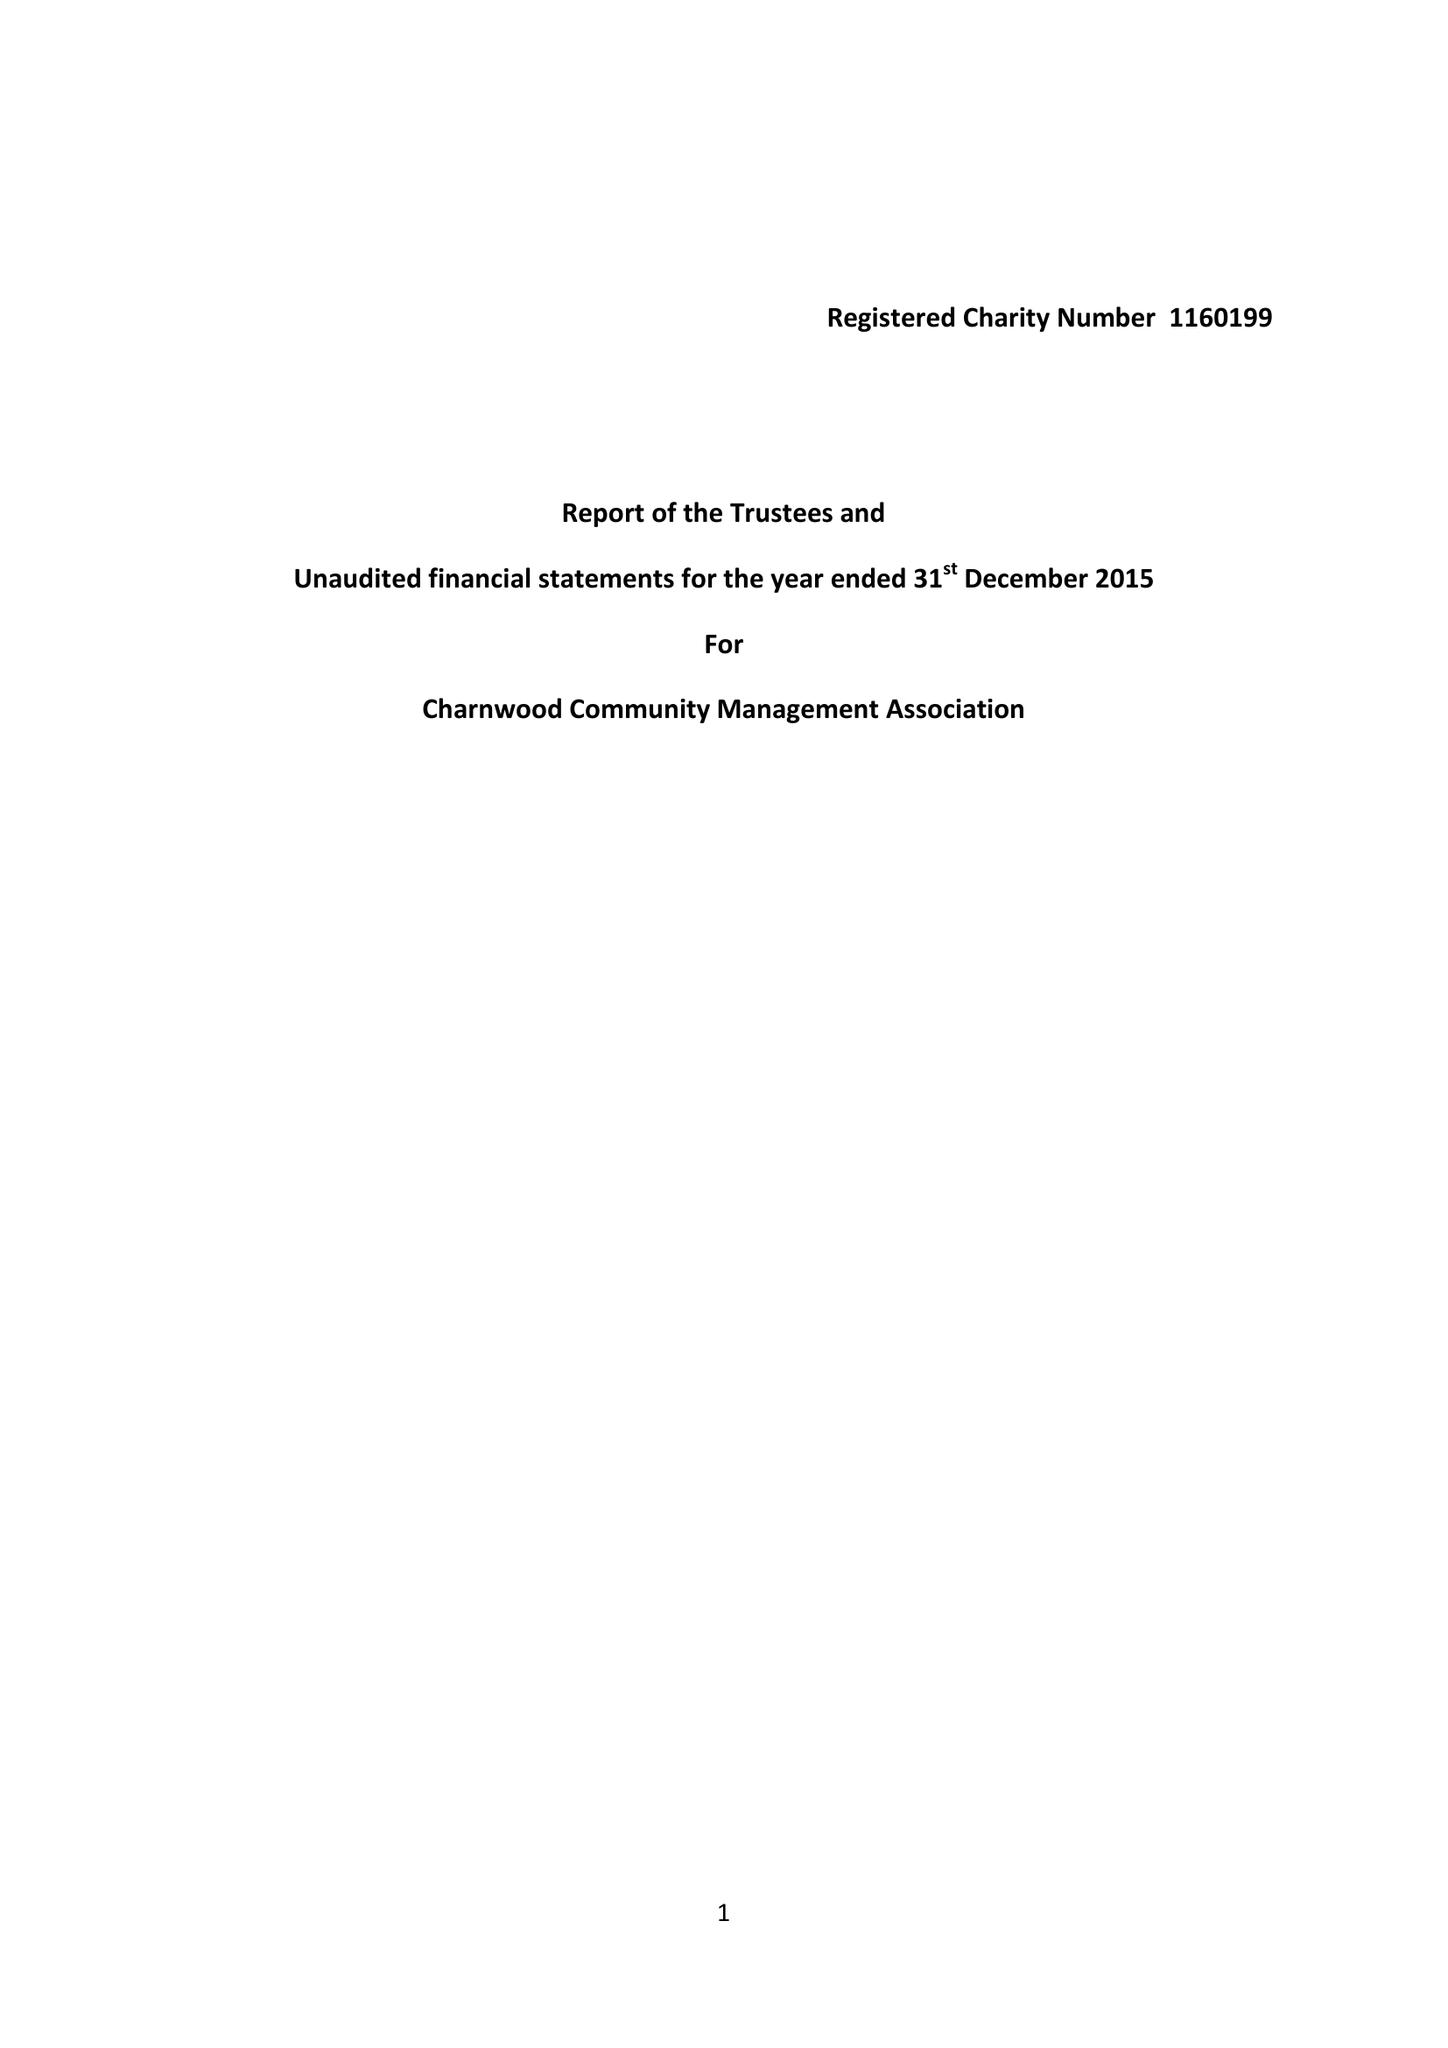What is the value for the income_annually_in_british_pounds?
Answer the question using a single word or phrase. 7221.84 